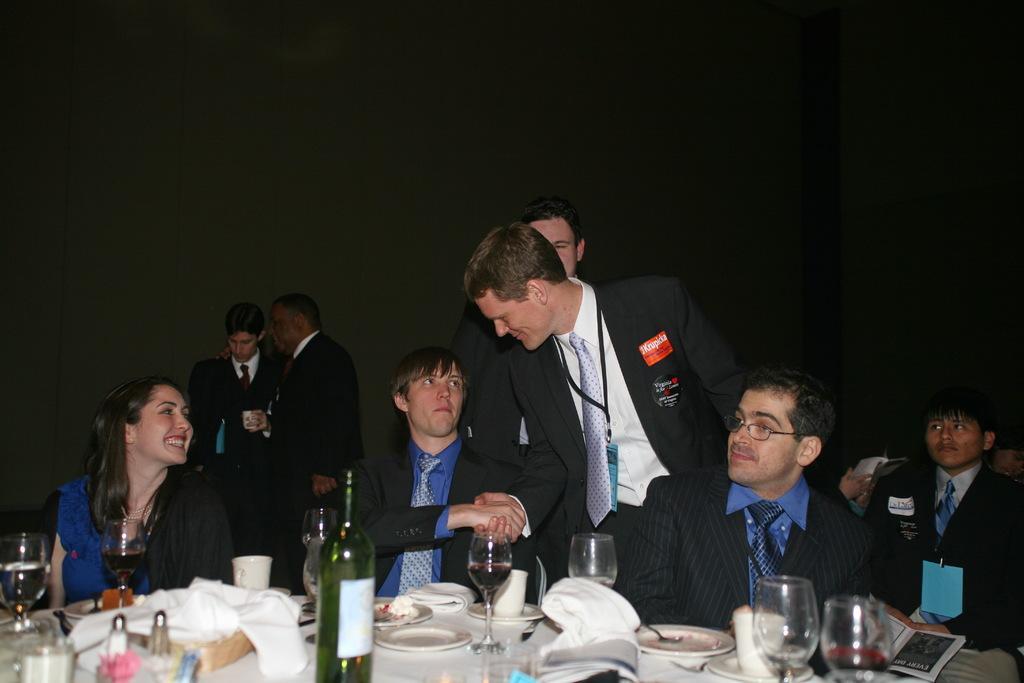In one or two sentences, can you explain what this image depicts? In the foreground of the picture there are tables, on the tables there are glasses, plates, clothes, jars, drinks, bottle, books and other objects. In the center of the picture there are people, few are standing and few are sitting. The background is black. 